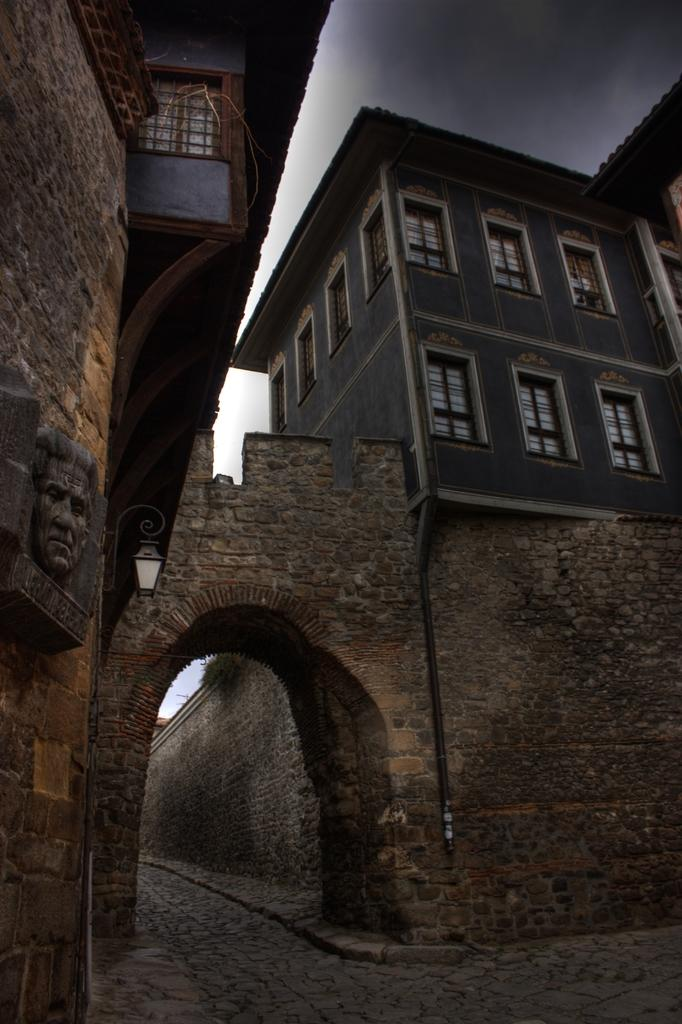What type of structures are present in the image? There are buildings in the image. What feature do the buildings have? The buildings have windows. What artistic object can be seen in the image? There is a sculpture in the image. Where is the lamp located in the image? There is a lamp on the wall in the image. What type of development is taking place in the image? There is no indication of any development taking place in the image; it primarily features buildings, a sculpture, and a lamp. What color is the silver start in the image? There is no silver start present in the image. 